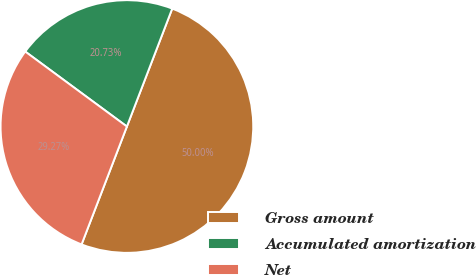Convert chart. <chart><loc_0><loc_0><loc_500><loc_500><pie_chart><fcel>Gross amount<fcel>Accumulated amortization<fcel>Net<nl><fcel>50.0%<fcel>20.73%<fcel>29.27%<nl></chart> 